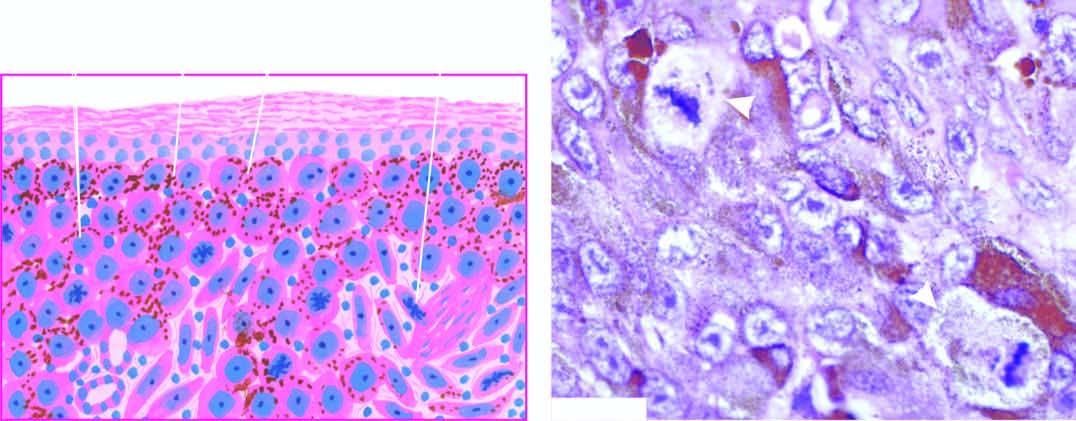re tumour cells resembling epithelioid cells with pleomorphic nuclei and prominent nucleoli seen as solid masses in the dermis?
Answer the question using a single word or phrase. Yes 